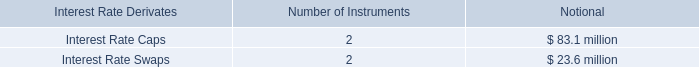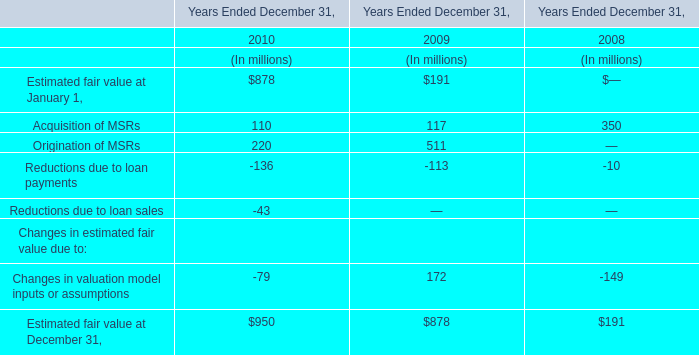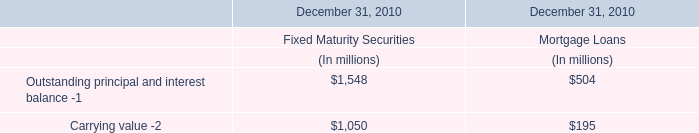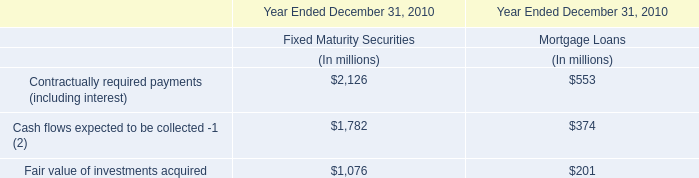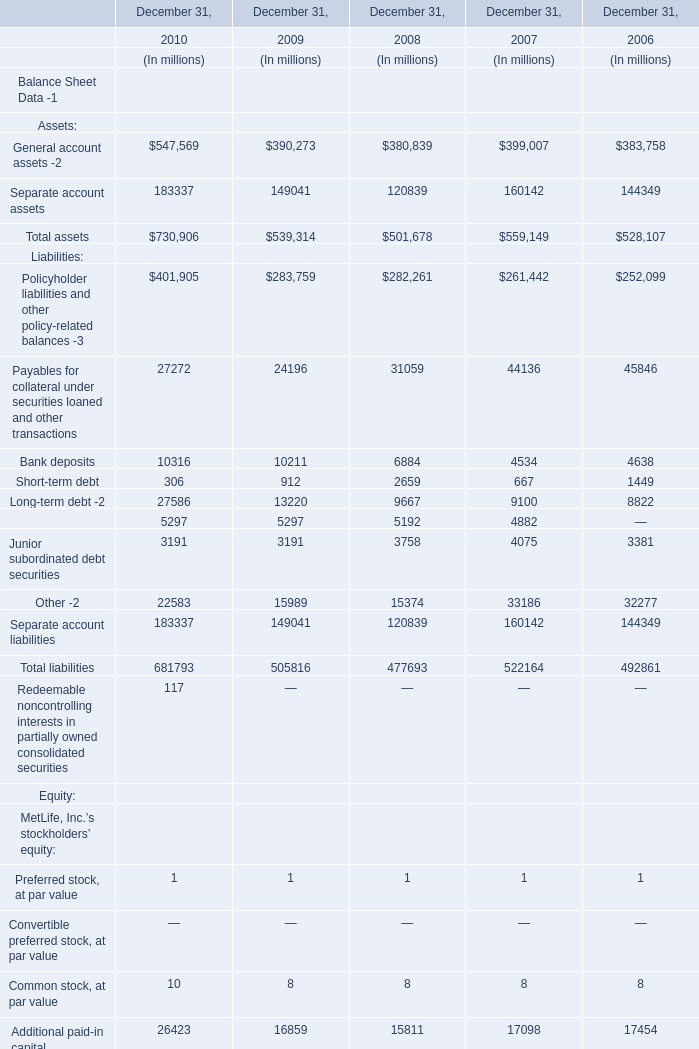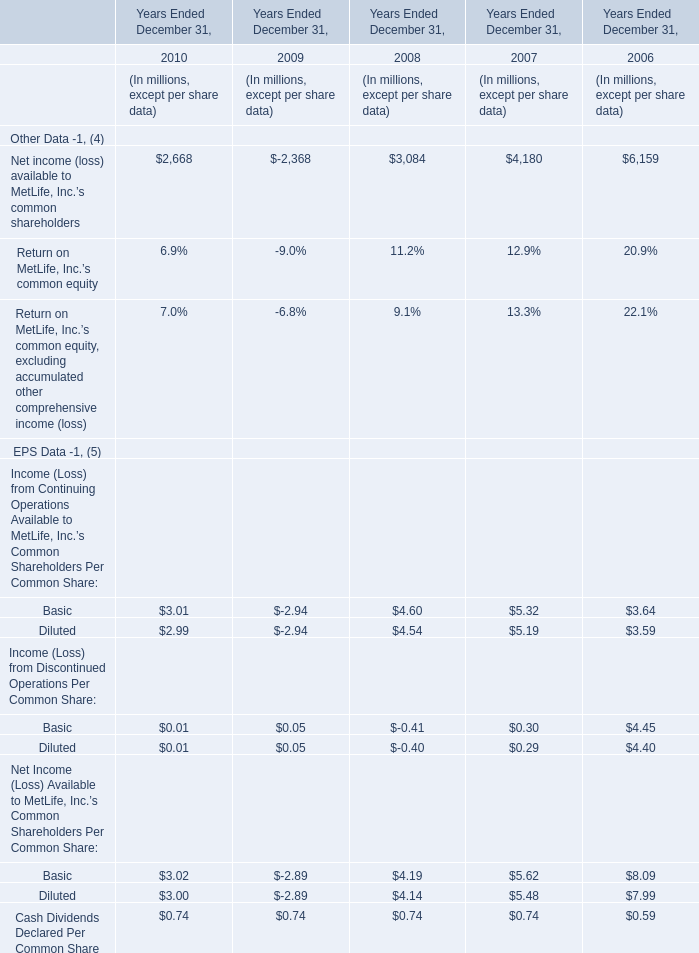Which year is rate for Return on MetLife, Inc.’s common equity, excluding accumulated other comprehensive income (loss) the highest? 
Answer: 2006. 